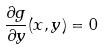<formula> <loc_0><loc_0><loc_500><loc_500>\frac { \partial g } { \partial y } ( x , y ) = 0</formula> 